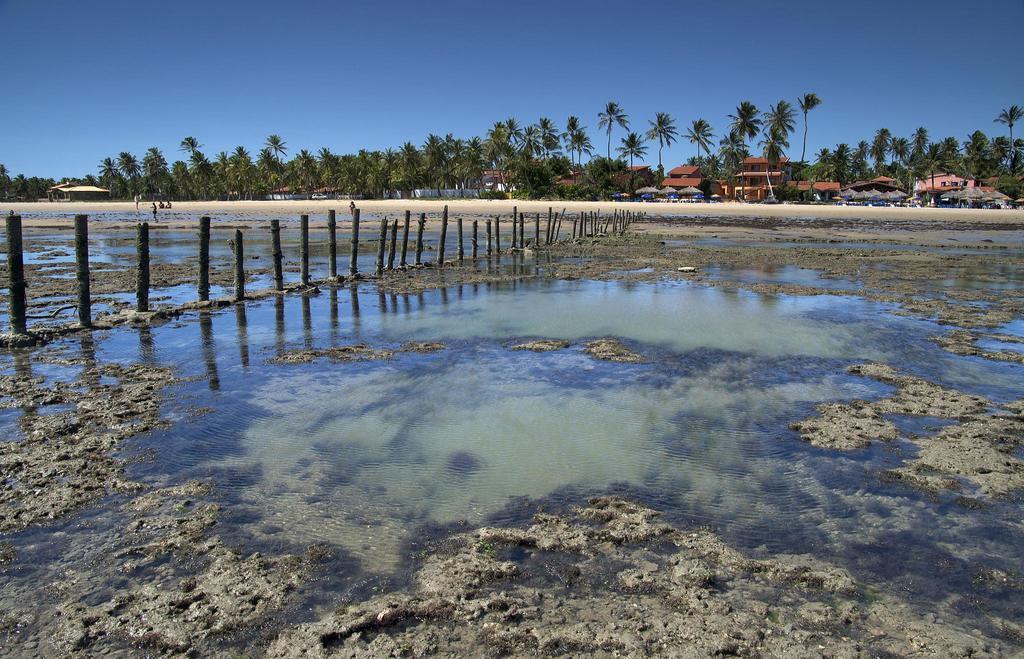How would you summarize this image in a sentence or two? In the center of the image we can see water, poles and mud. In the background, we can see the sky, trees, buildings, few people etc. 